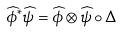<formula> <loc_0><loc_0><loc_500><loc_500>\widehat { \phi } ^ { * } \widehat { \psi } = \widehat { \phi } \otimes \widehat { \psi } \circ \Delta</formula> 